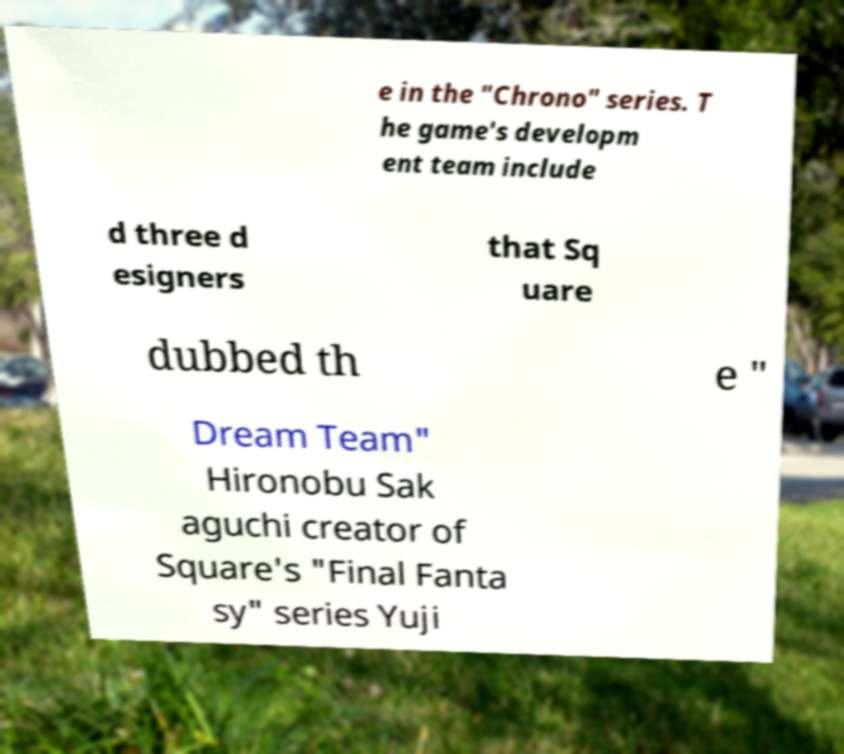Please read and relay the text visible in this image. What does it say? e in the "Chrono" series. T he game's developm ent team include d three d esigners that Sq uare dubbed th e " Dream Team" Hironobu Sak aguchi creator of Square's "Final Fanta sy" series Yuji 